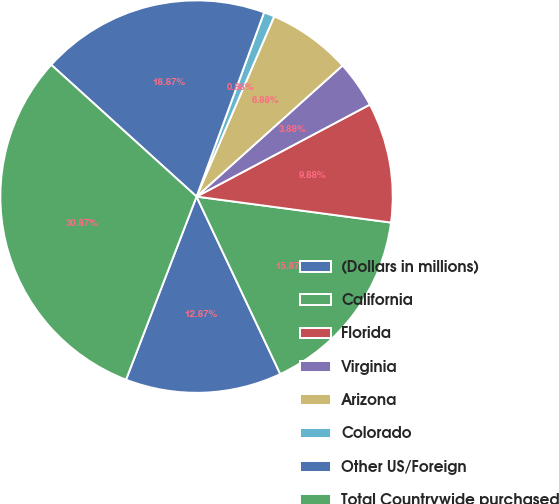Convert chart. <chart><loc_0><loc_0><loc_500><loc_500><pie_chart><fcel>(Dollars in millions)<fcel>California<fcel>Florida<fcel>Virginia<fcel>Arizona<fcel>Colorado<fcel>Other US/Foreign<fcel>Total Countrywide purchased<nl><fcel>12.87%<fcel>15.87%<fcel>9.88%<fcel>3.88%<fcel>6.88%<fcel>0.88%<fcel>18.87%<fcel>30.87%<nl></chart> 